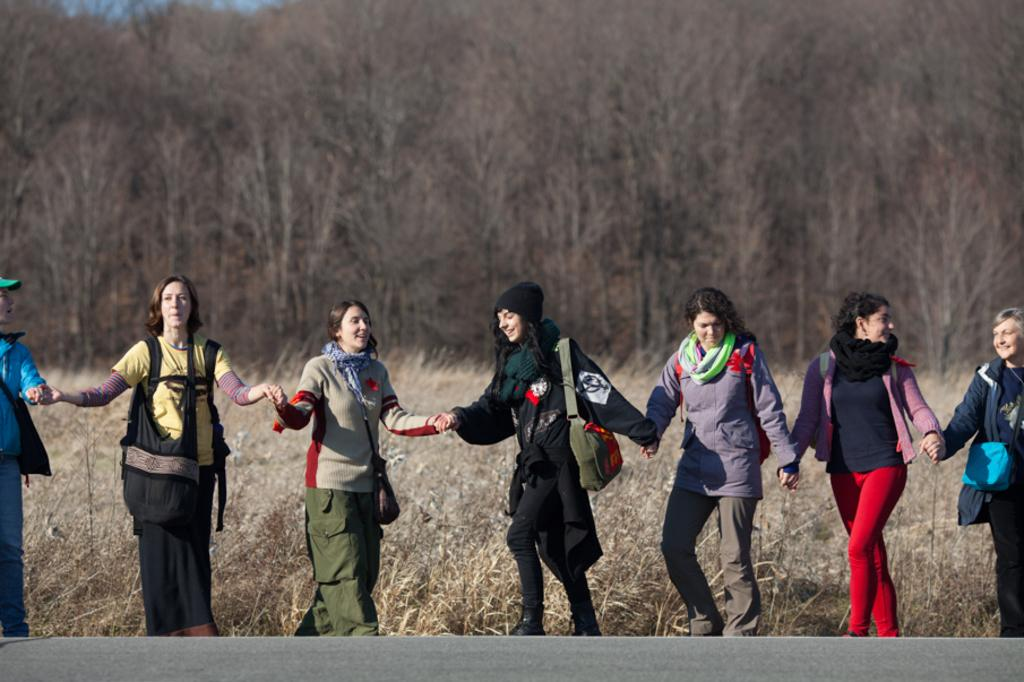How many women are present in the image? There are seven women standing in the image. What are the women doing in the image? The women are holding each other's hands. What is the ground like in the image? The scene appears to be on dried grass. What can be seen in the background of the image? There are trees in the background of the image. What are the women wearing that might be used for carrying items? The women are wearing bags. What type of linen can be seen draped over the trees in the image? There is no linen draped over the trees in the image; the trees are visible in the background without any additional items. 